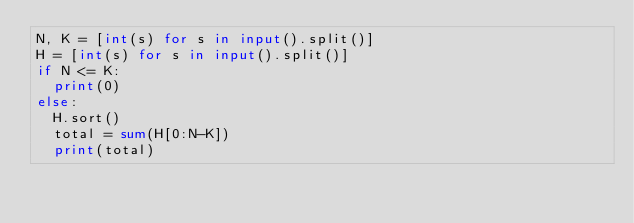<code> <loc_0><loc_0><loc_500><loc_500><_Python_>N, K = [int(s) for s in input().split()]
H = [int(s) for s in input().split()]
if N <= K:
  print(0)
else:
  H.sort()
  total = sum(H[0:N-K])
  print(total)
</code> 